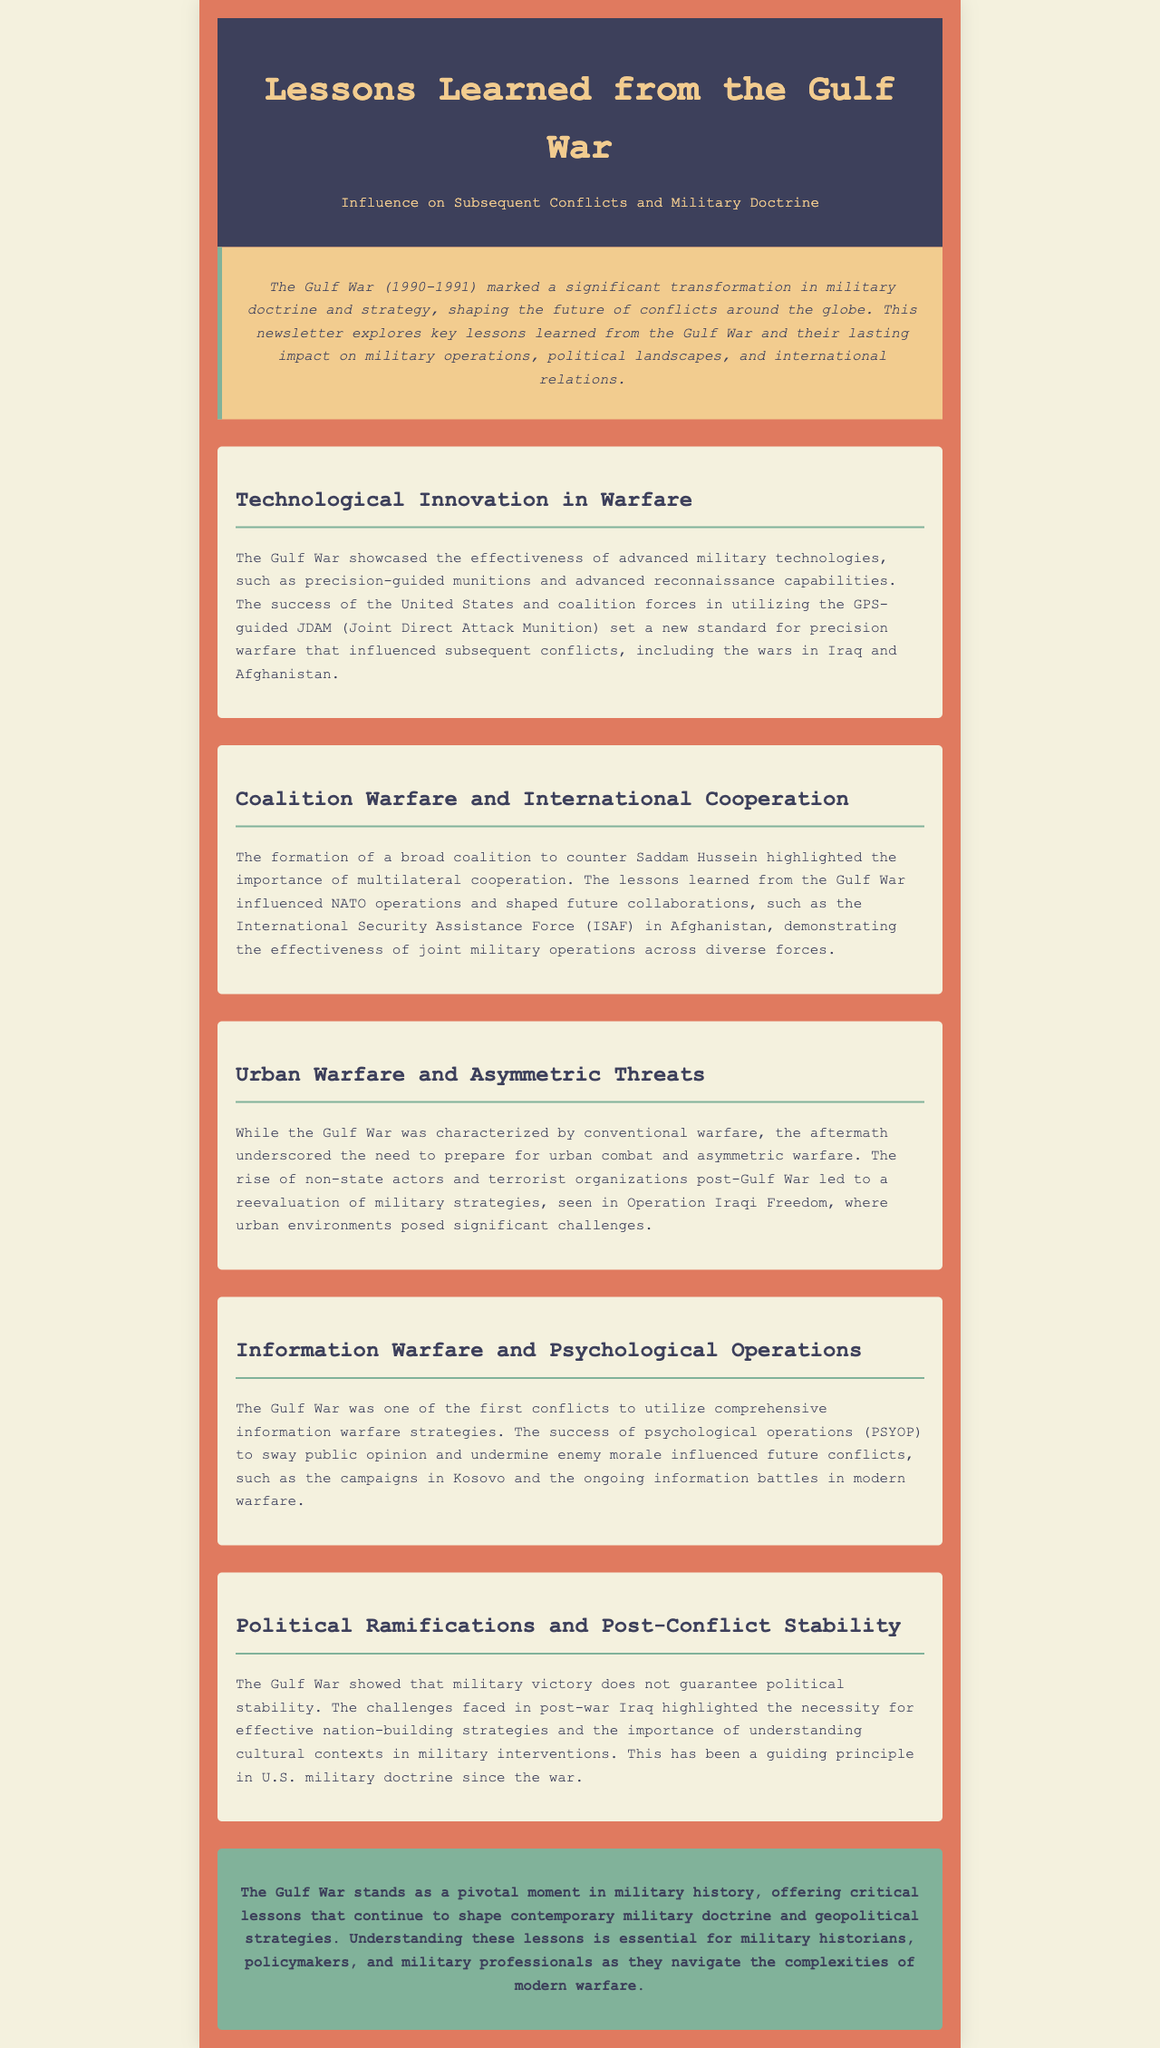What was a significant transformation in military doctrine during the Gulf War? The document states that the Gulf War marked a significant transformation in military doctrine and strategy.
Answer: Military doctrine Which operation is mentioned in relation to urban warfare challenges? The document refers to Operation Iraqi Freedom as an example of a military conflict where urban environments posed significant challenges.
Answer: Operation Iraqi Freedom What advanced technology significantly influenced precision warfare? The text highlights the effectiveness of GPS-guided JDAM (Joint Direct Attack Munition) as a standard for precision warfare.
Answer: GPS-guided JDAM What was one outcome of the coalition formed during the Gulf War? The Gulf War's coalition warfare influenced NATO operations and shaped collaborations like the International Security Assistance Force in Afghanistan.
Answer: NATO operations What was one key political lesson learned from the Gulf War? The document emphasizes that military victory does not guarantee political stability as a key political lesson.
Answer: Military victory What type of warfare strategies were comprehensive during the Gulf War? The document states that the Gulf War utilized comprehensive information warfare strategies.
Answer: Information warfare strategies What does the conclusion emphasize about the Gulf War's significance? The conclusion mentions that the Gulf War is a pivotal moment in military history that offers critical lessons shaping contemporary military doctrine.
Answer: Pivotal moment What aspect of warfare did the Gulf War highlight related to non-state actors? The document indicates that the aftermath of the Gulf War underscored the need to prepare for asymmetric warfare due to the rise of non-state actors.
Answer: Asymmetric warfare 